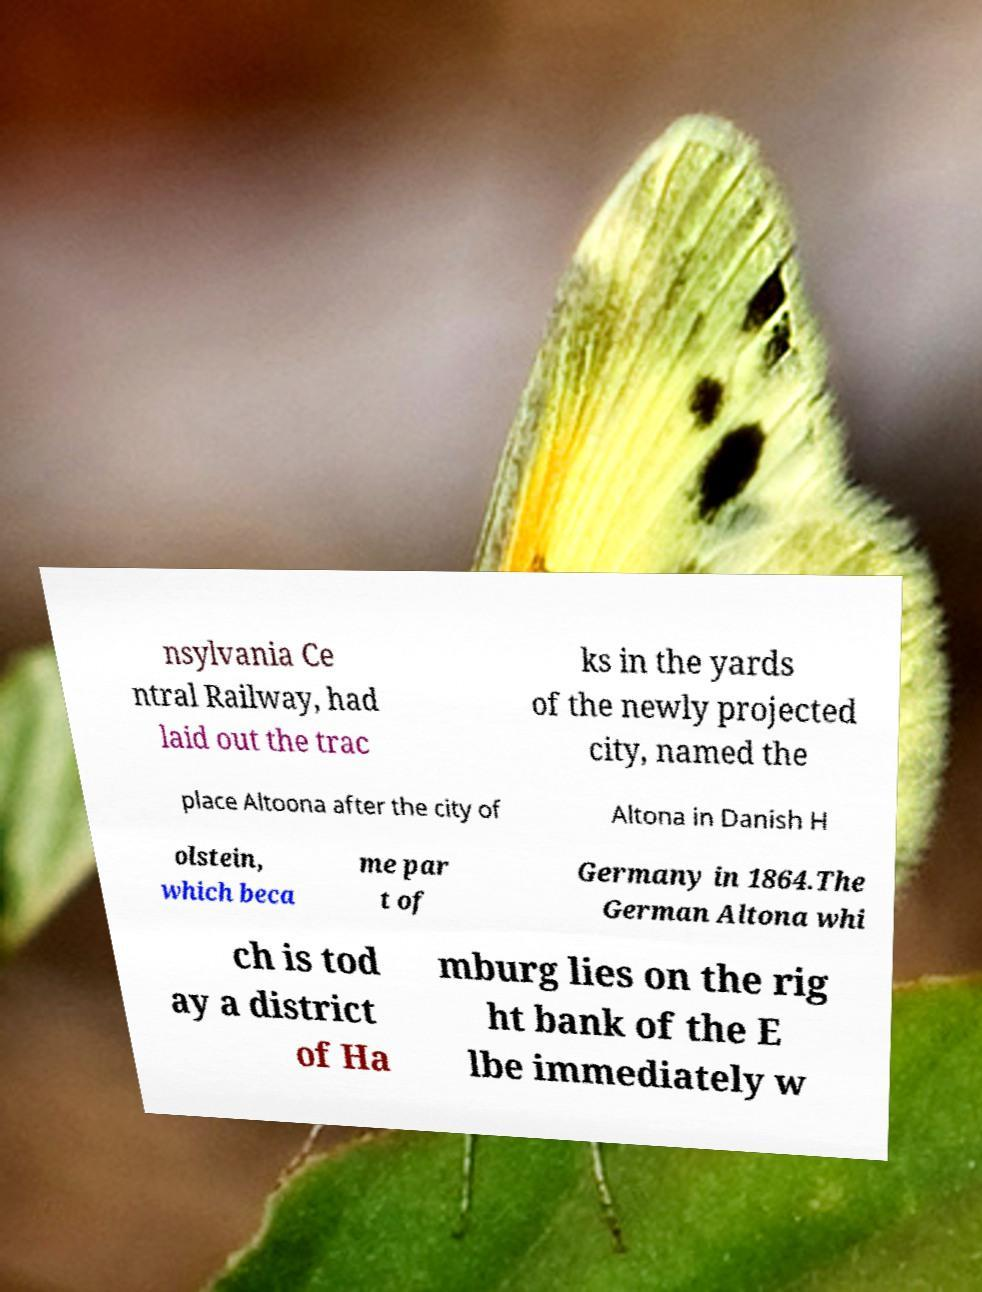I need the written content from this picture converted into text. Can you do that? nsylvania Ce ntral Railway, had laid out the trac ks in the yards of the newly projected city, named the place Altoona after the city of Altona in Danish H olstein, which beca me par t of Germany in 1864.The German Altona whi ch is tod ay a district of Ha mburg lies on the rig ht bank of the E lbe immediately w 